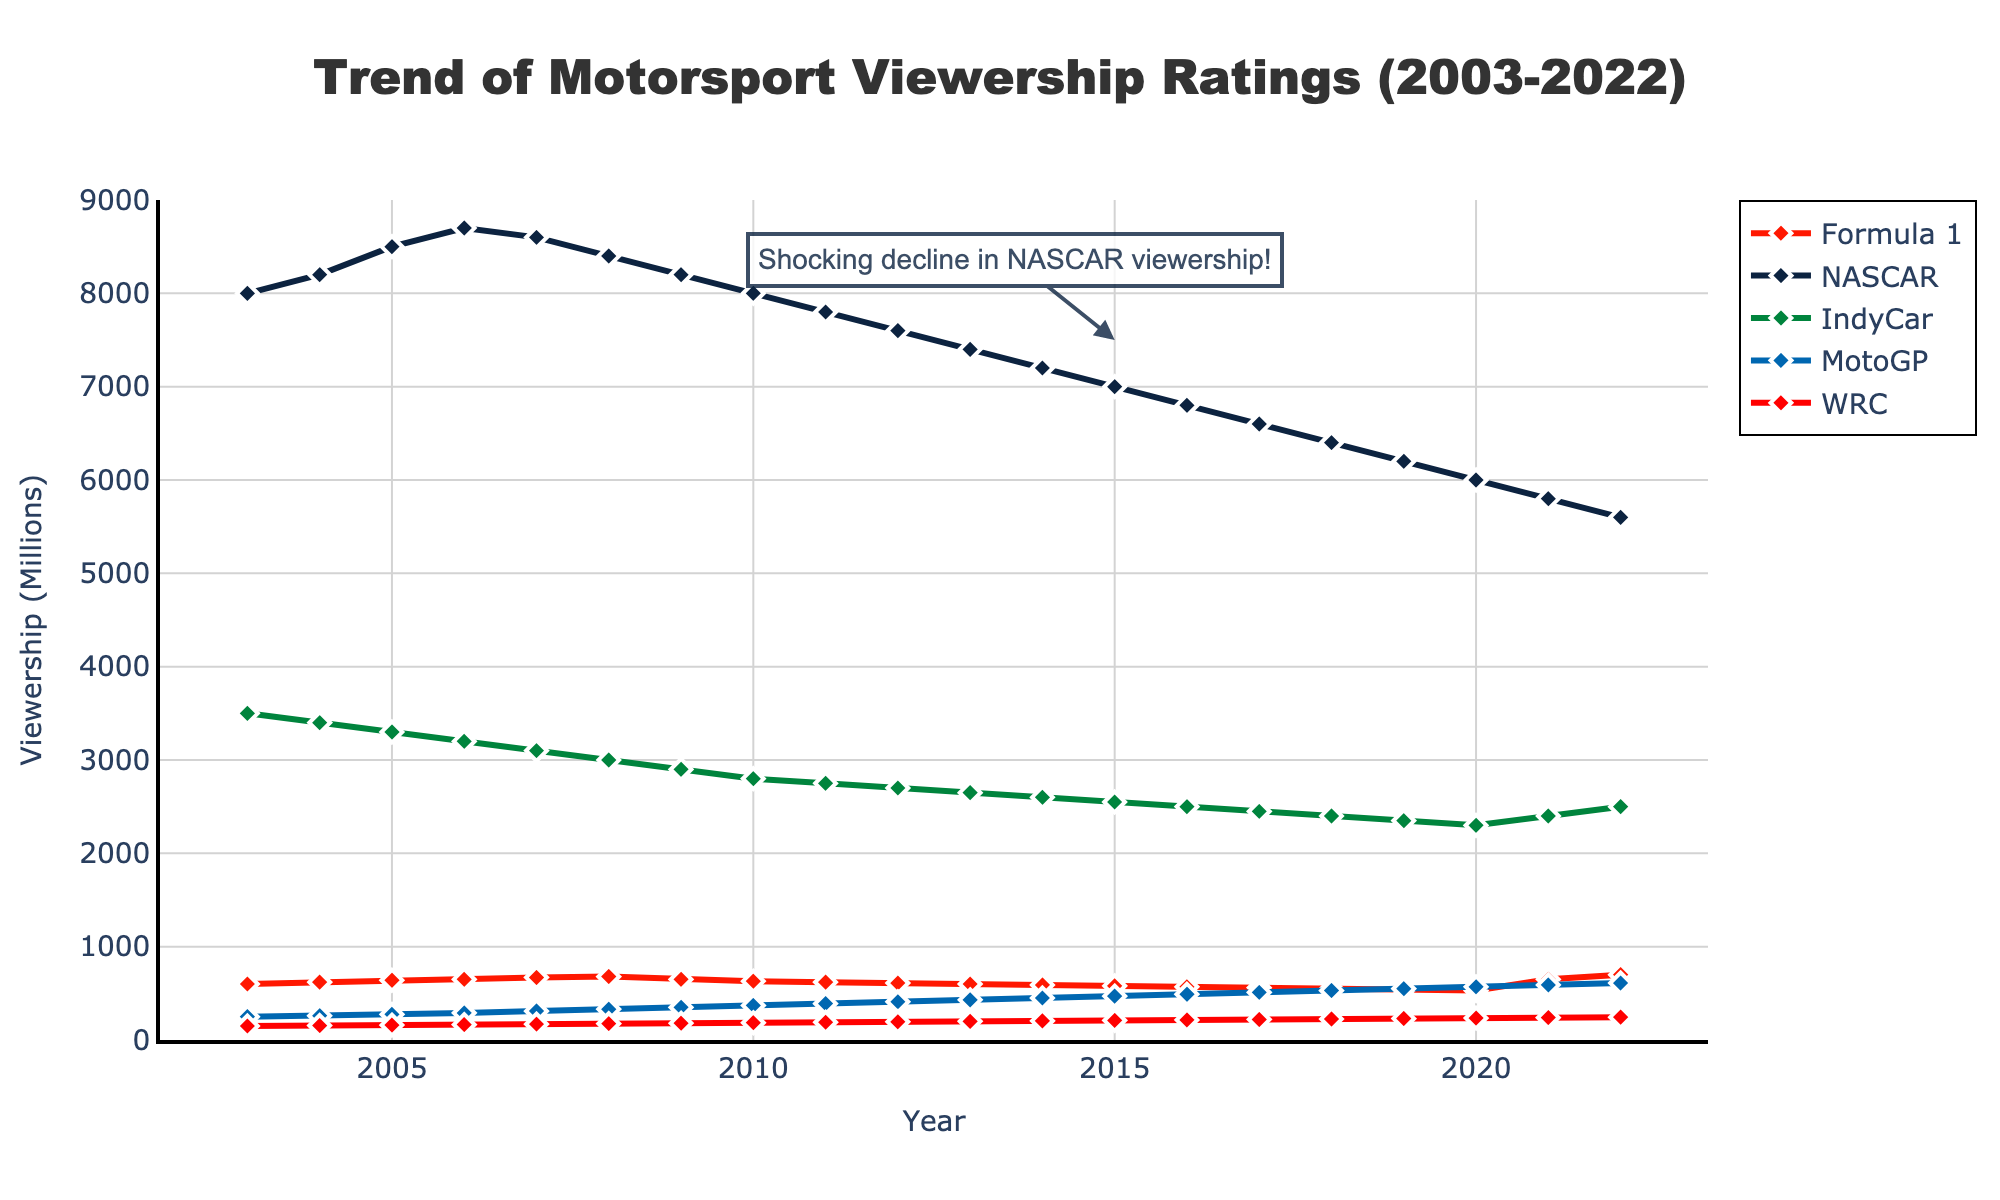Which series had the highest viewership in 2022? Look for the highest point on the y-axis in the year 2022. Formula 1 has the highest viewership among the series listed with 700 million.
Answer: Formula 1 Which series experienced the most significant decline in viewership over the two decades? Calculate the difference between the initial and final years for each series. NASCAR declined from 8000 million in 2003 to 5600 million in 2022, the most significant drop.
Answer: NASCAR What is the combined viewership of MotoGP across the two decades from 2003 to 2022? Add the viewership values for MotoGP from 2003 to 2022: 250 + 260 + ... + 610. The result is the sum of all MotoGP viewership ratings over the years.
Answer: 9980 million Which series saw a notable increase in viewership after 2020? Compare the ratings from 2020 to 2022 for each series. Formula 1 increased from 530 in 2020 to 700 in 2022, showing a notable rise.
Answer: Formula 1 What was the overall trend for WRC viewership over the two decades? Observe the plotted line for WRC from left (2003) to right (2022). WRC viewership generally increased from 150 in 2003 to 245 in 2022.
Answer: Increasing Compare the viewership of NASCAR and IndyCar in 2010. Which one had more viewers? Look at the values for 2010 for both NASCAR and IndyCar. NASCAR had 8000, whereas IndyCar had 2800, so NASCAR had more viewers.
Answer: NASCAR What was the average viewership for Formula 1 from 2003 to 2022? Calculate the average by summing all Formula 1 viewership values and then dividing by the number of years (20). The average is (600+620+...+700)/20 = 613
Answer: 613 Notice the annotation "Shocking decline in NASCAR viewership!" What years mark the most considerable drop mentioned? Look directly at the years surrounding the annotation (around 2015). NASCAR viewership dropped from about 7000 in 2015 to 5800 in 2021, the sharpest decline within a few years.
Answer: 2015-2021 Which series had relatively stable viewership with minor fluctuations over the years? Observe each line's general trend for overall stability. WRC experienced minor yearly fluctuations but generally trended upwards steadily.
Answer: WRC In which year did Formula 1 and IndyCar have nearly the same viewership? Find the year where the lines for Formula 1 and IndyCar come closest. In 2021, both series had viewership rates close to 2400 million.
Answer: 2021 